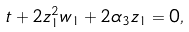Convert formula to latex. <formula><loc_0><loc_0><loc_500><loc_500>t + 2 z _ { 1 } ^ { 2 } w _ { 1 } + 2 \alpha _ { 3 } z _ { 1 } = 0 ,</formula> 